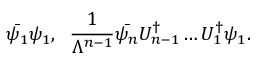Convert formula to latex. <formula><loc_0><loc_0><loc_500><loc_500>\bar { \psi _ { 1 } } \psi _ { 1 } , \, \frac { 1 } { \Lambda ^ { n - 1 } } \bar { \psi _ { n } } U _ { n - 1 } ^ { \dagger } \dots U _ { 1 } ^ { \dagger } \psi _ { 1 } .</formula> 